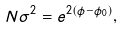Convert formula to latex. <formula><loc_0><loc_0><loc_500><loc_500>N \sigma ^ { 2 } = e ^ { 2 ( \phi - \phi _ { 0 } ) } ,</formula> 